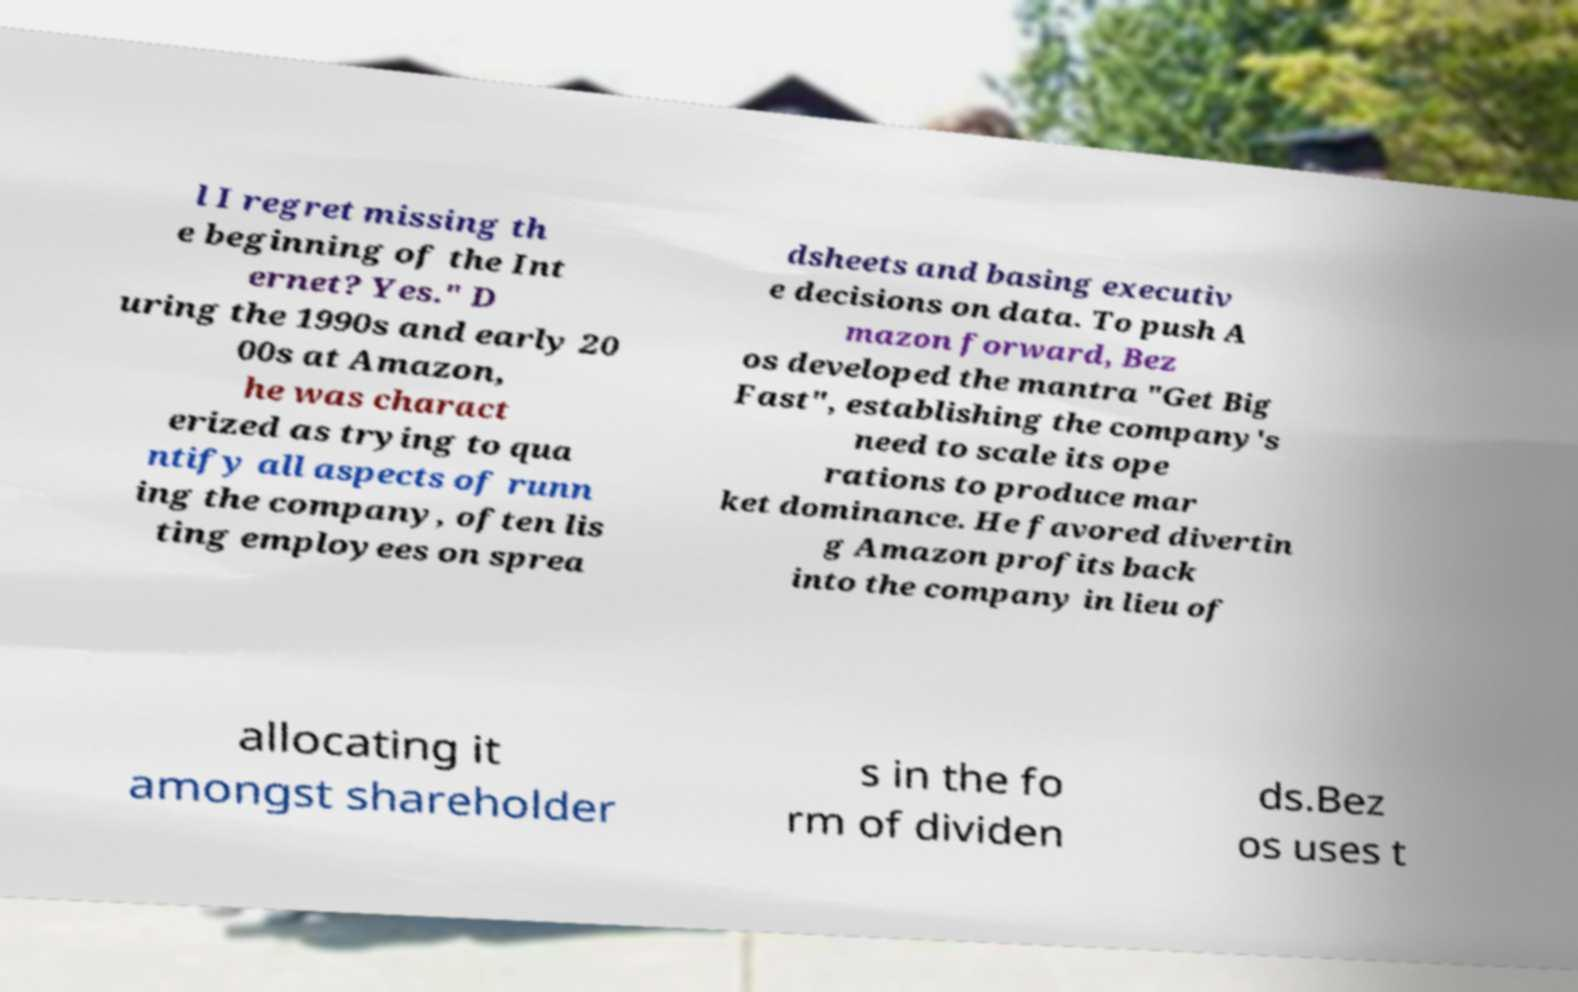Could you extract and type out the text from this image? l I regret missing th e beginning of the Int ernet? Yes." D uring the 1990s and early 20 00s at Amazon, he was charact erized as trying to qua ntify all aspects of runn ing the company, often lis ting employees on sprea dsheets and basing executiv e decisions on data. To push A mazon forward, Bez os developed the mantra "Get Big Fast", establishing the company's need to scale its ope rations to produce mar ket dominance. He favored divertin g Amazon profits back into the company in lieu of allocating it amongst shareholder s in the fo rm of dividen ds.Bez os uses t 